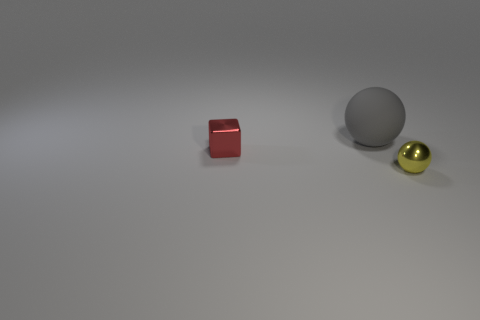Is there anything else that has the same size as the rubber ball?
Give a very brief answer. No. Are there any other things that are the same material as the big sphere?
Your answer should be very brief. No. What is the color of the other tiny object that is the same shape as the gray rubber object?
Provide a succinct answer. Yellow. There is a sphere that is behind the tiny red cube; what number of shiny things are on the right side of it?
Make the answer very short. 1. How many balls are either big cyan things or red objects?
Make the answer very short. 0. Are any cyan balls visible?
Ensure brevity in your answer.  No. The other thing that is the same shape as the big matte thing is what size?
Provide a short and direct response. Small. The small thing in front of the metallic object that is to the left of the tiny sphere is what shape?
Ensure brevity in your answer.  Sphere. How many cyan things are balls or metallic cubes?
Keep it short and to the point. 0. What color is the tiny shiny ball?
Provide a short and direct response. Yellow. 